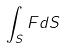Convert formula to latex. <formula><loc_0><loc_0><loc_500><loc_500>\int _ { S } F d S</formula> 